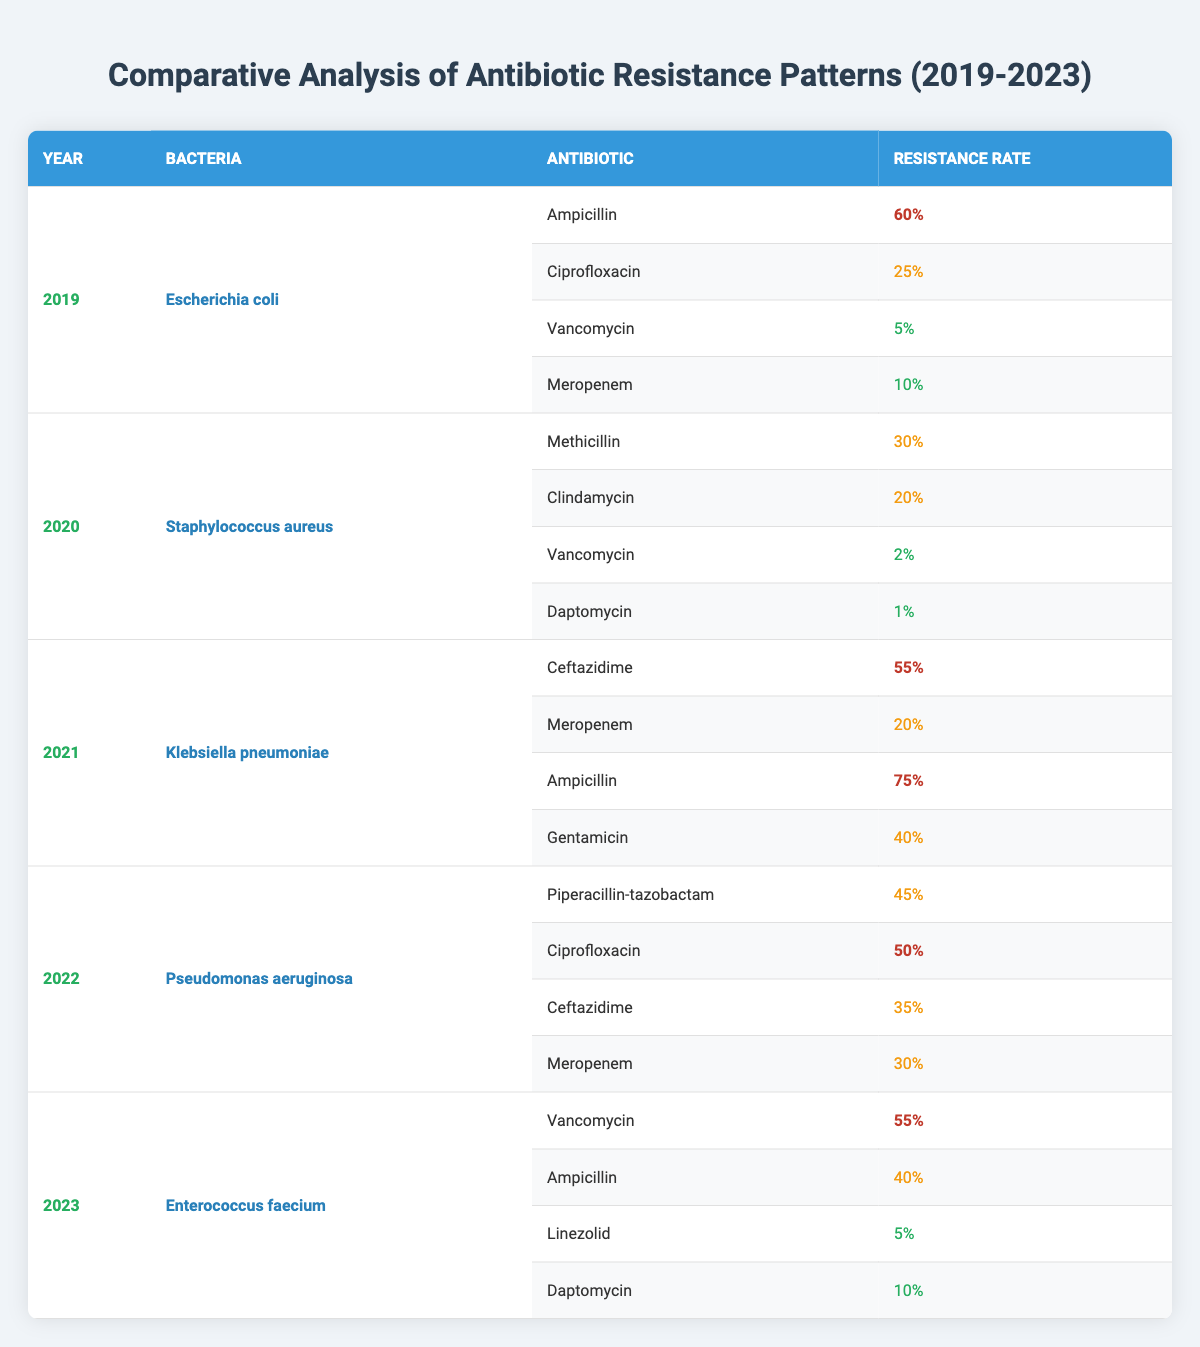What is the resistance rate of Ampicillin in Escherichia coli for the year 2019? The table indicates that in 2019, the resistance rate for Ampicillin in Escherichia coli is listed as 60%.
Answer: 60% What was the percentage of resistance to Methicillin in Staphylococcus aureus in 2020? According to the table, in 2020, the resistance rate to Methicillin in Staphylococcus aureus is 30%.
Answer: 30% Which bacteria had the highest resistance rate to Ampicillin? The table shows that Klebsiella pneumoniae had the highest resistance rate to Ampicillin at 75% in 2021.
Answer: Klebsiella pneumoniae What is the total percentage of resistance to Vancomycin in the years represented? Adding the resistance rates from all years where Vancomycin is listed gives us (5% + 2% + 0% + 0% + 55%) = 62%.
Answer: 62% Which year had the highest resistance rate for Ciprofloxacin and what was that rate? The highest resistance rate for Ciprofloxacin is 50%, which occurred in the year 2022 according to the table.
Answer: 2022, 50% Is there any year where the resistance rate to Daptomycin was higher than 10%? The table indicates that in 2021, Daptomycin had a resistance rate of 1%, and in 2023, it was 10%, so there was no year where the resistance was higher than 10%.
Answer: No Which antibiotic had the highest resistance percentage in 2022, and what was the percentage? In 2022, Ciprofloxacin had the highest resistance percentage at 50%, compared to other antibiotics listed for that year.
Answer: Ciprofloxacin, 50% What is the average resistance rate for Vancomycin across all years? The resistance rates for Vancomycin across all years are (5% + 2% + 0% + 0% + 55%) which sums up to 62%. There are 5 data points, which gives an average of 62%/5 = 12.4%.
Answer: 12.4% Between 2019 and 2023, which bacterium showed the highest fluctuation in resistance for the antibiotics listed and how? By examining resistance rates, Klebsiella pneumoniae’s resistance to Ampicillin varied from 75% in 2021, while other bacteria showed smaller fluctuations. Therefore, its variation shows the highest fluctuation.
Answer: Klebsiella pneumoniae Is Staphylococcus aureus consistently resistant to Vancomycin from 2019 to 2023? The table shows that Staphylococcus aureus had a resistance rate of 2% to Vancomycin in 2020 and no data for other years, so we cannot state consistent resistance across those years.
Answer: No 